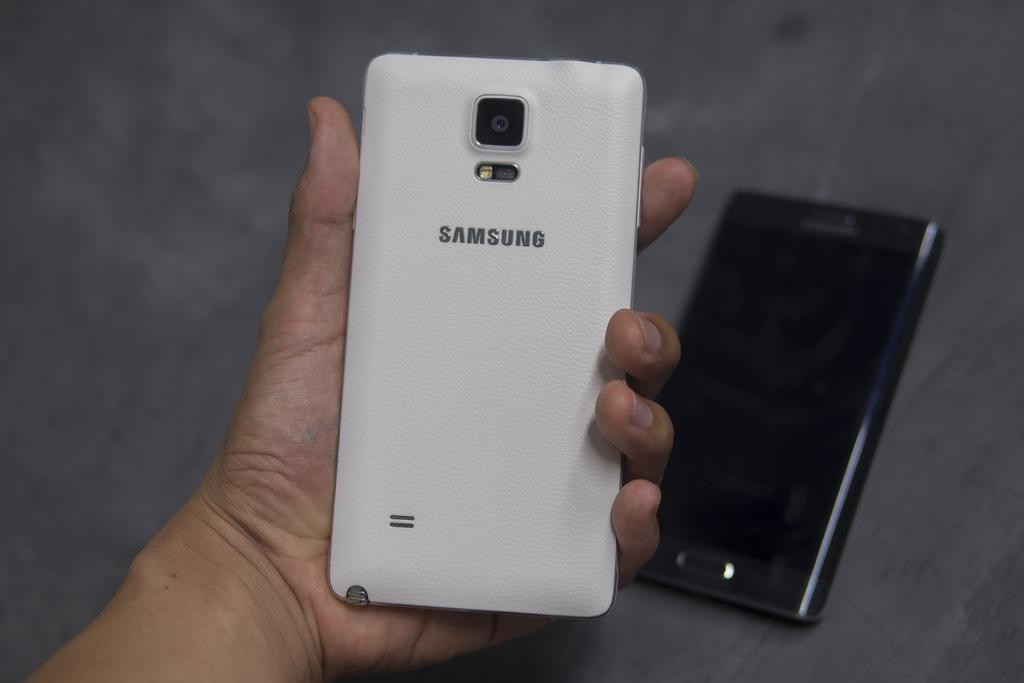Provide a one-sentence caption for the provided image. A white Samsung phone is held in a person's open hand and another phone sits on a table in the background. 